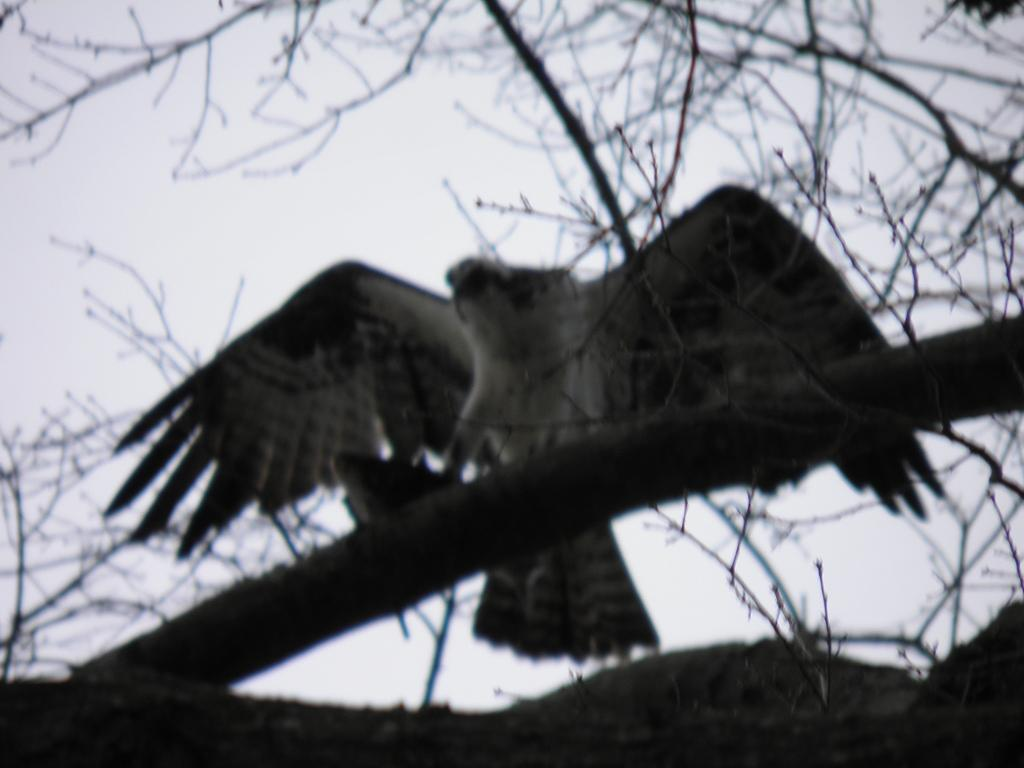What type of animal can be seen in the image? There is a bird in the image. Where is the bird located? The bird is on a tree. What is visible at the top of the image? The sky is visible at the top of the image. How many pins are holding the bird to the tree in the image? There are no pins present in the image; the bird is naturally perched on the tree. 